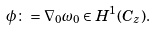Convert formula to latex. <formula><loc_0><loc_0><loc_500><loc_500>\phi \colon = \nabla _ { 0 } \omega _ { 0 } \in H ^ { 1 } ( C _ { z } ) .</formula> 